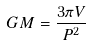<formula> <loc_0><loc_0><loc_500><loc_500>G M = \frac { 3 \pi V } { P ^ { 2 } }</formula> 